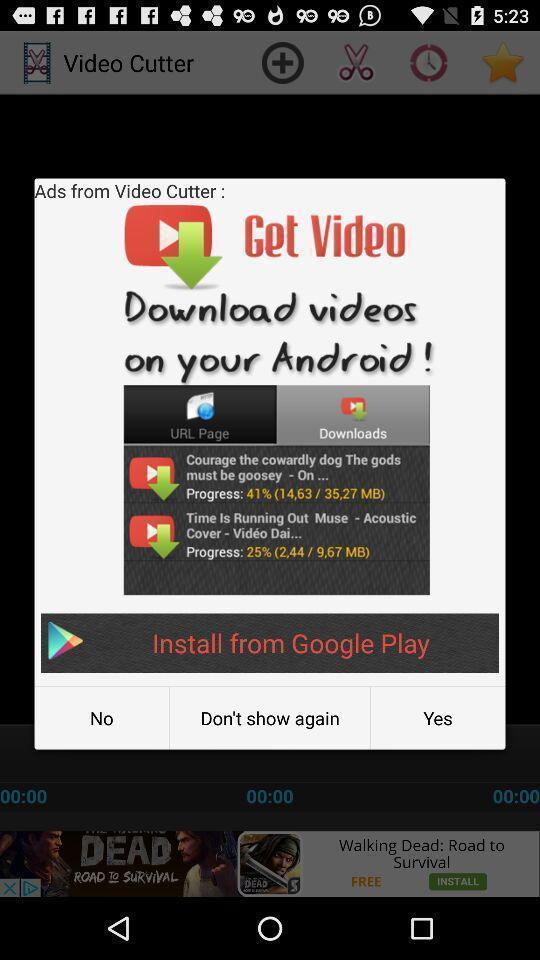Explain what's happening in this screen capture. Pop-up displaying application to install. 